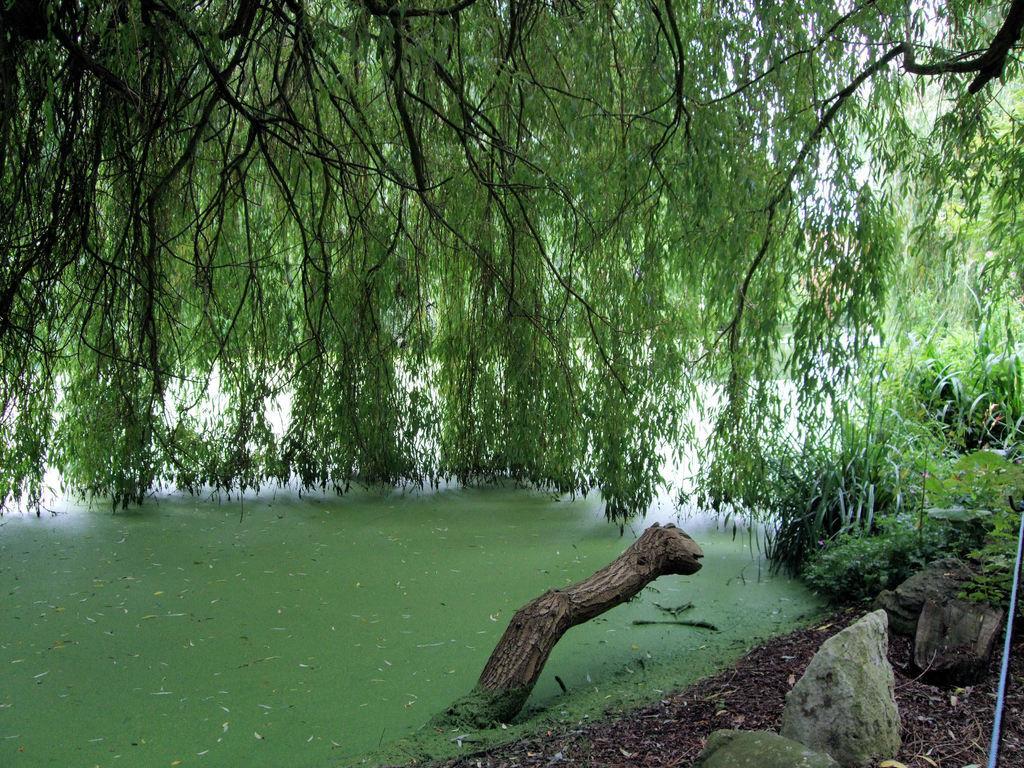Describe this image in one or two sentences. At the bottom of the image there are some stones and water and plants. In the middle of the image there are some trees. 